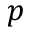Convert formula to latex. <formula><loc_0><loc_0><loc_500><loc_500>p</formula> 